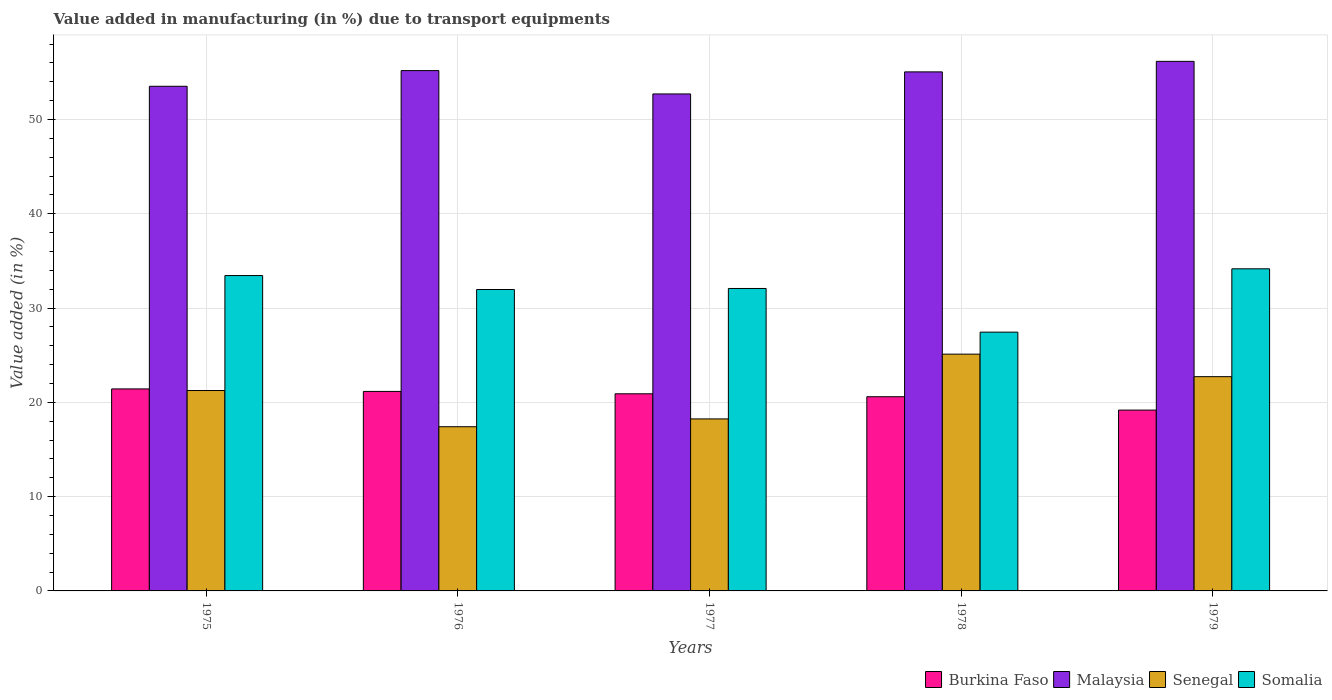How many different coloured bars are there?
Keep it short and to the point. 4. How many groups of bars are there?
Your answer should be compact. 5. What is the percentage of value added in manufacturing due to transport equipments in Somalia in 1978?
Ensure brevity in your answer.  27.45. Across all years, what is the maximum percentage of value added in manufacturing due to transport equipments in Somalia?
Offer a very short reply. 34.16. Across all years, what is the minimum percentage of value added in manufacturing due to transport equipments in Malaysia?
Keep it short and to the point. 52.71. In which year was the percentage of value added in manufacturing due to transport equipments in Somalia maximum?
Provide a short and direct response. 1979. In which year was the percentage of value added in manufacturing due to transport equipments in Burkina Faso minimum?
Ensure brevity in your answer.  1979. What is the total percentage of value added in manufacturing due to transport equipments in Malaysia in the graph?
Give a very brief answer. 272.64. What is the difference between the percentage of value added in manufacturing due to transport equipments in Malaysia in 1975 and that in 1979?
Make the answer very short. -2.65. What is the difference between the percentage of value added in manufacturing due to transport equipments in Somalia in 1975 and the percentage of value added in manufacturing due to transport equipments in Malaysia in 1979?
Offer a very short reply. -22.72. What is the average percentage of value added in manufacturing due to transport equipments in Senegal per year?
Ensure brevity in your answer.  20.95. In the year 1978, what is the difference between the percentage of value added in manufacturing due to transport equipments in Burkina Faso and percentage of value added in manufacturing due to transport equipments in Malaysia?
Your response must be concise. -34.45. In how many years, is the percentage of value added in manufacturing due to transport equipments in Somalia greater than 36 %?
Your answer should be compact. 0. What is the ratio of the percentage of value added in manufacturing due to transport equipments in Malaysia in 1975 to that in 1977?
Ensure brevity in your answer.  1.02. Is the percentage of value added in manufacturing due to transport equipments in Burkina Faso in 1976 less than that in 1977?
Provide a short and direct response. No. Is the difference between the percentage of value added in manufacturing due to transport equipments in Burkina Faso in 1975 and 1976 greater than the difference between the percentage of value added in manufacturing due to transport equipments in Malaysia in 1975 and 1976?
Your response must be concise. Yes. What is the difference between the highest and the second highest percentage of value added in manufacturing due to transport equipments in Senegal?
Your answer should be compact. 2.39. What is the difference between the highest and the lowest percentage of value added in manufacturing due to transport equipments in Somalia?
Keep it short and to the point. 6.72. In how many years, is the percentage of value added in manufacturing due to transport equipments in Somalia greater than the average percentage of value added in manufacturing due to transport equipments in Somalia taken over all years?
Give a very brief answer. 4. What does the 4th bar from the left in 1975 represents?
Provide a short and direct response. Somalia. What does the 4th bar from the right in 1978 represents?
Your answer should be compact. Burkina Faso. How many bars are there?
Offer a very short reply. 20. Are all the bars in the graph horizontal?
Provide a succinct answer. No. Does the graph contain grids?
Ensure brevity in your answer.  Yes. How are the legend labels stacked?
Give a very brief answer. Horizontal. What is the title of the graph?
Your response must be concise. Value added in manufacturing (in %) due to transport equipments. What is the label or title of the Y-axis?
Keep it short and to the point. Value added (in %). What is the Value added (in %) in Burkina Faso in 1975?
Provide a short and direct response. 21.43. What is the Value added (in %) in Malaysia in 1975?
Provide a short and direct response. 53.52. What is the Value added (in %) of Senegal in 1975?
Provide a short and direct response. 21.26. What is the Value added (in %) of Somalia in 1975?
Your response must be concise. 33.45. What is the Value added (in %) in Burkina Faso in 1976?
Offer a terse response. 21.16. What is the Value added (in %) of Malaysia in 1976?
Make the answer very short. 55.19. What is the Value added (in %) in Senegal in 1976?
Keep it short and to the point. 17.42. What is the Value added (in %) of Somalia in 1976?
Provide a succinct answer. 31.97. What is the Value added (in %) of Burkina Faso in 1977?
Ensure brevity in your answer.  20.91. What is the Value added (in %) in Malaysia in 1977?
Ensure brevity in your answer.  52.71. What is the Value added (in %) in Senegal in 1977?
Ensure brevity in your answer.  18.24. What is the Value added (in %) in Somalia in 1977?
Offer a terse response. 32.08. What is the Value added (in %) in Burkina Faso in 1978?
Offer a terse response. 20.6. What is the Value added (in %) of Malaysia in 1978?
Give a very brief answer. 55.05. What is the Value added (in %) of Senegal in 1978?
Offer a terse response. 25.11. What is the Value added (in %) of Somalia in 1978?
Keep it short and to the point. 27.45. What is the Value added (in %) in Burkina Faso in 1979?
Offer a terse response. 19.18. What is the Value added (in %) in Malaysia in 1979?
Your response must be concise. 56.17. What is the Value added (in %) in Senegal in 1979?
Your answer should be compact. 22.72. What is the Value added (in %) in Somalia in 1979?
Provide a short and direct response. 34.16. Across all years, what is the maximum Value added (in %) in Burkina Faso?
Your answer should be compact. 21.43. Across all years, what is the maximum Value added (in %) in Malaysia?
Your response must be concise. 56.17. Across all years, what is the maximum Value added (in %) in Senegal?
Provide a succinct answer. 25.11. Across all years, what is the maximum Value added (in %) in Somalia?
Your answer should be very brief. 34.16. Across all years, what is the minimum Value added (in %) of Burkina Faso?
Provide a succinct answer. 19.18. Across all years, what is the minimum Value added (in %) in Malaysia?
Your answer should be very brief. 52.71. Across all years, what is the minimum Value added (in %) in Senegal?
Make the answer very short. 17.42. Across all years, what is the minimum Value added (in %) in Somalia?
Give a very brief answer. 27.45. What is the total Value added (in %) in Burkina Faso in the graph?
Offer a very short reply. 103.27. What is the total Value added (in %) in Malaysia in the graph?
Your response must be concise. 272.64. What is the total Value added (in %) in Senegal in the graph?
Keep it short and to the point. 104.75. What is the total Value added (in %) of Somalia in the graph?
Provide a succinct answer. 159.11. What is the difference between the Value added (in %) of Burkina Faso in 1975 and that in 1976?
Make the answer very short. 0.26. What is the difference between the Value added (in %) in Malaysia in 1975 and that in 1976?
Make the answer very short. -1.67. What is the difference between the Value added (in %) in Senegal in 1975 and that in 1976?
Your response must be concise. 3.84. What is the difference between the Value added (in %) in Somalia in 1975 and that in 1976?
Keep it short and to the point. 1.48. What is the difference between the Value added (in %) in Burkina Faso in 1975 and that in 1977?
Provide a short and direct response. 0.52. What is the difference between the Value added (in %) of Malaysia in 1975 and that in 1977?
Provide a succinct answer. 0.81. What is the difference between the Value added (in %) in Senegal in 1975 and that in 1977?
Offer a very short reply. 3.01. What is the difference between the Value added (in %) in Somalia in 1975 and that in 1977?
Provide a short and direct response. 1.37. What is the difference between the Value added (in %) in Burkina Faso in 1975 and that in 1978?
Keep it short and to the point. 0.83. What is the difference between the Value added (in %) of Malaysia in 1975 and that in 1978?
Offer a very short reply. -1.53. What is the difference between the Value added (in %) in Senegal in 1975 and that in 1978?
Your answer should be very brief. -3.86. What is the difference between the Value added (in %) in Somalia in 1975 and that in 1978?
Provide a succinct answer. 6. What is the difference between the Value added (in %) of Burkina Faso in 1975 and that in 1979?
Offer a very short reply. 2.25. What is the difference between the Value added (in %) in Malaysia in 1975 and that in 1979?
Your response must be concise. -2.65. What is the difference between the Value added (in %) of Senegal in 1975 and that in 1979?
Make the answer very short. -1.47. What is the difference between the Value added (in %) in Somalia in 1975 and that in 1979?
Provide a short and direct response. -0.71. What is the difference between the Value added (in %) in Burkina Faso in 1976 and that in 1977?
Offer a terse response. 0.25. What is the difference between the Value added (in %) of Malaysia in 1976 and that in 1977?
Your answer should be compact. 2.48. What is the difference between the Value added (in %) of Senegal in 1976 and that in 1977?
Offer a very short reply. -0.83. What is the difference between the Value added (in %) of Somalia in 1976 and that in 1977?
Provide a succinct answer. -0.11. What is the difference between the Value added (in %) of Burkina Faso in 1976 and that in 1978?
Offer a terse response. 0.56. What is the difference between the Value added (in %) in Malaysia in 1976 and that in 1978?
Make the answer very short. 0.14. What is the difference between the Value added (in %) of Senegal in 1976 and that in 1978?
Your answer should be compact. -7.7. What is the difference between the Value added (in %) in Somalia in 1976 and that in 1978?
Provide a short and direct response. 4.52. What is the difference between the Value added (in %) in Burkina Faso in 1976 and that in 1979?
Provide a short and direct response. 1.98. What is the difference between the Value added (in %) of Malaysia in 1976 and that in 1979?
Your response must be concise. -0.98. What is the difference between the Value added (in %) in Senegal in 1976 and that in 1979?
Offer a terse response. -5.31. What is the difference between the Value added (in %) of Somalia in 1976 and that in 1979?
Offer a very short reply. -2.19. What is the difference between the Value added (in %) in Burkina Faso in 1977 and that in 1978?
Offer a very short reply. 0.31. What is the difference between the Value added (in %) in Malaysia in 1977 and that in 1978?
Provide a succinct answer. -2.34. What is the difference between the Value added (in %) of Senegal in 1977 and that in 1978?
Keep it short and to the point. -6.87. What is the difference between the Value added (in %) of Somalia in 1977 and that in 1978?
Your answer should be very brief. 4.63. What is the difference between the Value added (in %) of Burkina Faso in 1977 and that in 1979?
Your answer should be compact. 1.73. What is the difference between the Value added (in %) of Malaysia in 1977 and that in 1979?
Your response must be concise. -3.46. What is the difference between the Value added (in %) of Senegal in 1977 and that in 1979?
Ensure brevity in your answer.  -4.48. What is the difference between the Value added (in %) in Somalia in 1977 and that in 1979?
Provide a short and direct response. -2.09. What is the difference between the Value added (in %) in Burkina Faso in 1978 and that in 1979?
Your answer should be compact. 1.42. What is the difference between the Value added (in %) in Malaysia in 1978 and that in 1979?
Offer a terse response. -1.12. What is the difference between the Value added (in %) in Senegal in 1978 and that in 1979?
Offer a very short reply. 2.39. What is the difference between the Value added (in %) of Somalia in 1978 and that in 1979?
Offer a terse response. -6.72. What is the difference between the Value added (in %) in Burkina Faso in 1975 and the Value added (in %) in Malaysia in 1976?
Provide a succinct answer. -33.76. What is the difference between the Value added (in %) in Burkina Faso in 1975 and the Value added (in %) in Senegal in 1976?
Make the answer very short. 4.01. What is the difference between the Value added (in %) in Burkina Faso in 1975 and the Value added (in %) in Somalia in 1976?
Your response must be concise. -10.54. What is the difference between the Value added (in %) in Malaysia in 1975 and the Value added (in %) in Senegal in 1976?
Make the answer very short. 36.11. What is the difference between the Value added (in %) in Malaysia in 1975 and the Value added (in %) in Somalia in 1976?
Offer a terse response. 21.55. What is the difference between the Value added (in %) in Senegal in 1975 and the Value added (in %) in Somalia in 1976?
Your answer should be compact. -10.71. What is the difference between the Value added (in %) of Burkina Faso in 1975 and the Value added (in %) of Malaysia in 1977?
Make the answer very short. -31.29. What is the difference between the Value added (in %) of Burkina Faso in 1975 and the Value added (in %) of Senegal in 1977?
Your answer should be very brief. 3.18. What is the difference between the Value added (in %) of Burkina Faso in 1975 and the Value added (in %) of Somalia in 1977?
Provide a succinct answer. -10.65. What is the difference between the Value added (in %) of Malaysia in 1975 and the Value added (in %) of Senegal in 1977?
Give a very brief answer. 35.28. What is the difference between the Value added (in %) of Malaysia in 1975 and the Value added (in %) of Somalia in 1977?
Make the answer very short. 21.44. What is the difference between the Value added (in %) of Senegal in 1975 and the Value added (in %) of Somalia in 1977?
Ensure brevity in your answer.  -10.82. What is the difference between the Value added (in %) of Burkina Faso in 1975 and the Value added (in %) of Malaysia in 1978?
Provide a short and direct response. -33.63. What is the difference between the Value added (in %) of Burkina Faso in 1975 and the Value added (in %) of Senegal in 1978?
Your response must be concise. -3.69. What is the difference between the Value added (in %) of Burkina Faso in 1975 and the Value added (in %) of Somalia in 1978?
Offer a very short reply. -6.02. What is the difference between the Value added (in %) in Malaysia in 1975 and the Value added (in %) in Senegal in 1978?
Your answer should be very brief. 28.41. What is the difference between the Value added (in %) of Malaysia in 1975 and the Value added (in %) of Somalia in 1978?
Offer a terse response. 26.08. What is the difference between the Value added (in %) of Senegal in 1975 and the Value added (in %) of Somalia in 1978?
Your answer should be very brief. -6.19. What is the difference between the Value added (in %) in Burkina Faso in 1975 and the Value added (in %) in Malaysia in 1979?
Offer a terse response. -34.74. What is the difference between the Value added (in %) in Burkina Faso in 1975 and the Value added (in %) in Senegal in 1979?
Your answer should be compact. -1.3. What is the difference between the Value added (in %) of Burkina Faso in 1975 and the Value added (in %) of Somalia in 1979?
Your response must be concise. -12.74. What is the difference between the Value added (in %) of Malaysia in 1975 and the Value added (in %) of Senegal in 1979?
Your answer should be very brief. 30.8. What is the difference between the Value added (in %) in Malaysia in 1975 and the Value added (in %) in Somalia in 1979?
Your response must be concise. 19.36. What is the difference between the Value added (in %) of Senegal in 1975 and the Value added (in %) of Somalia in 1979?
Provide a succinct answer. -12.91. What is the difference between the Value added (in %) of Burkina Faso in 1976 and the Value added (in %) of Malaysia in 1977?
Keep it short and to the point. -31.55. What is the difference between the Value added (in %) of Burkina Faso in 1976 and the Value added (in %) of Senegal in 1977?
Your answer should be compact. 2.92. What is the difference between the Value added (in %) of Burkina Faso in 1976 and the Value added (in %) of Somalia in 1977?
Keep it short and to the point. -10.92. What is the difference between the Value added (in %) in Malaysia in 1976 and the Value added (in %) in Senegal in 1977?
Ensure brevity in your answer.  36.94. What is the difference between the Value added (in %) of Malaysia in 1976 and the Value added (in %) of Somalia in 1977?
Provide a short and direct response. 23.11. What is the difference between the Value added (in %) of Senegal in 1976 and the Value added (in %) of Somalia in 1977?
Your answer should be compact. -14.66. What is the difference between the Value added (in %) of Burkina Faso in 1976 and the Value added (in %) of Malaysia in 1978?
Provide a succinct answer. -33.89. What is the difference between the Value added (in %) in Burkina Faso in 1976 and the Value added (in %) in Senegal in 1978?
Keep it short and to the point. -3.95. What is the difference between the Value added (in %) in Burkina Faso in 1976 and the Value added (in %) in Somalia in 1978?
Your answer should be compact. -6.29. What is the difference between the Value added (in %) in Malaysia in 1976 and the Value added (in %) in Senegal in 1978?
Your answer should be very brief. 30.07. What is the difference between the Value added (in %) in Malaysia in 1976 and the Value added (in %) in Somalia in 1978?
Ensure brevity in your answer.  27.74. What is the difference between the Value added (in %) of Senegal in 1976 and the Value added (in %) of Somalia in 1978?
Keep it short and to the point. -10.03. What is the difference between the Value added (in %) in Burkina Faso in 1976 and the Value added (in %) in Malaysia in 1979?
Ensure brevity in your answer.  -35.01. What is the difference between the Value added (in %) of Burkina Faso in 1976 and the Value added (in %) of Senegal in 1979?
Give a very brief answer. -1.56. What is the difference between the Value added (in %) of Burkina Faso in 1976 and the Value added (in %) of Somalia in 1979?
Make the answer very short. -13. What is the difference between the Value added (in %) of Malaysia in 1976 and the Value added (in %) of Senegal in 1979?
Make the answer very short. 32.46. What is the difference between the Value added (in %) of Malaysia in 1976 and the Value added (in %) of Somalia in 1979?
Your answer should be very brief. 21.02. What is the difference between the Value added (in %) in Senegal in 1976 and the Value added (in %) in Somalia in 1979?
Give a very brief answer. -16.75. What is the difference between the Value added (in %) of Burkina Faso in 1977 and the Value added (in %) of Malaysia in 1978?
Offer a terse response. -34.14. What is the difference between the Value added (in %) in Burkina Faso in 1977 and the Value added (in %) in Senegal in 1978?
Your answer should be very brief. -4.2. What is the difference between the Value added (in %) in Burkina Faso in 1977 and the Value added (in %) in Somalia in 1978?
Make the answer very short. -6.54. What is the difference between the Value added (in %) in Malaysia in 1977 and the Value added (in %) in Senegal in 1978?
Offer a very short reply. 27.6. What is the difference between the Value added (in %) in Malaysia in 1977 and the Value added (in %) in Somalia in 1978?
Offer a terse response. 25.27. What is the difference between the Value added (in %) of Senegal in 1977 and the Value added (in %) of Somalia in 1978?
Offer a very short reply. -9.2. What is the difference between the Value added (in %) of Burkina Faso in 1977 and the Value added (in %) of Malaysia in 1979?
Keep it short and to the point. -35.26. What is the difference between the Value added (in %) in Burkina Faso in 1977 and the Value added (in %) in Senegal in 1979?
Ensure brevity in your answer.  -1.82. What is the difference between the Value added (in %) of Burkina Faso in 1977 and the Value added (in %) of Somalia in 1979?
Provide a succinct answer. -13.25. What is the difference between the Value added (in %) of Malaysia in 1977 and the Value added (in %) of Senegal in 1979?
Make the answer very short. 29.99. What is the difference between the Value added (in %) in Malaysia in 1977 and the Value added (in %) in Somalia in 1979?
Keep it short and to the point. 18.55. What is the difference between the Value added (in %) of Senegal in 1977 and the Value added (in %) of Somalia in 1979?
Keep it short and to the point. -15.92. What is the difference between the Value added (in %) of Burkina Faso in 1978 and the Value added (in %) of Malaysia in 1979?
Make the answer very short. -35.57. What is the difference between the Value added (in %) of Burkina Faso in 1978 and the Value added (in %) of Senegal in 1979?
Ensure brevity in your answer.  -2.13. What is the difference between the Value added (in %) in Burkina Faso in 1978 and the Value added (in %) in Somalia in 1979?
Make the answer very short. -13.57. What is the difference between the Value added (in %) in Malaysia in 1978 and the Value added (in %) in Senegal in 1979?
Offer a very short reply. 32.33. What is the difference between the Value added (in %) of Malaysia in 1978 and the Value added (in %) of Somalia in 1979?
Ensure brevity in your answer.  20.89. What is the difference between the Value added (in %) in Senegal in 1978 and the Value added (in %) in Somalia in 1979?
Ensure brevity in your answer.  -9.05. What is the average Value added (in %) of Burkina Faso per year?
Make the answer very short. 20.65. What is the average Value added (in %) of Malaysia per year?
Give a very brief answer. 54.53. What is the average Value added (in %) in Senegal per year?
Make the answer very short. 20.95. What is the average Value added (in %) of Somalia per year?
Offer a terse response. 31.82. In the year 1975, what is the difference between the Value added (in %) of Burkina Faso and Value added (in %) of Malaysia?
Your response must be concise. -32.1. In the year 1975, what is the difference between the Value added (in %) in Burkina Faso and Value added (in %) in Senegal?
Offer a terse response. 0.17. In the year 1975, what is the difference between the Value added (in %) in Burkina Faso and Value added (in %) in Somalia?
Provide a short and direct response. -12.02. In the year 1975, what is the difference between the Value added (in %) in Malaysia and Value added (in %) in Senegal?
Your response must be concise. 32.27. In the year 1975, what is the difference between the Value added (in %) in Malaysia and Value added (in %) in Somalia?
Your answer should be very brief. 20.07. In the year 1975, what is the difference between the Value added (in %) in Senegal and Value added (in %) in Somalia?
Make the answer very short. -12.19. In the year 1976, what is the difference between the Value added (in %) in Burkina Faso and Value added (in %) in Malaysia?
Offer a terse response. -34.03. In the year 1976, what is the difference between the Value added (in %) of Burkina Faso and Value added (in %) of Senegal?
Your answer should be compact. 3.75. In the year 1976, what is the difference between the Value added (in %) in Burkina Faso and Value added (in %) in Somalia?
Offer a terse response. -10.81. In the year 1976, what is the difference between the Value added (in %) of Malaysia and Value added (in %) of Senegal?
Your response must be concise. 37.77. In the year 1976, what is the difference between the Value added (in %) in Malaysia and Value added (in %) in Somalia?
Keep it short and to the point. 23.22. In the year 1976, what is the difference between the Value added (in %) in Senegal and Value added (in %) in Somalia?
Ensure brevity in your answer.  -14.55. In the year 1977, what is the difference between the Value added (in %) in Burkina Faso and Value added (in %) in Malaysia?
Provide a succinct answer. -31.8. In the year 1977, what is the difference between the Value added (in %) in Burkina Faso and Value added (in %) in Senegal?
Offer a terse response. 2.67. In the year 1977, what is the difference between the Value added (in %) of Burkina Faso and Value added (in %) of Somalia?
Your answer should be very brief. -11.17. In the year 1977, what is the difference between the Value added (in %) in Malaysia and Value added (in %) in Senegal?
Offer a terse response. 34.47. In the year 1977, what is the difference between the Value added (in %) in Malaysia and Value added (in %) in Somalia?
Your response must be concise. 20.63. In the year 1977, what is the difference between the Value added (in %) in Senegal and Value added (in %) in Somalia?
Your answer should be very brief. -13.83. In the year 1978, what is the difference between the Value added (in %) in Burkina Faso and Value added (in %) in Malaysia?
Provide a succinct answer. -34.45. In the year 1978, what is the difference between the Value added (in %) in Burkina Faso and Value added (in %) in Senegal?
Offer a very short reply. -4.52. In the year 1978, what is the difference between the Value added (in %) of Burkina Faso and Value added (in %) of Somalia?
Provide a short and direct response. -6.85. In the year 1978, what is the difference between the Value added (in %) in Malaysia and Value added (in %) in Senegal?
Offer a very short reply. 29.94. In the year 1978, what is the difference between the Value added (in %) in Malaysia and Value added (in %) in Somalia?
Make the answer very short. 27.61. In the year 1978, what is the difference between the Value added (in %) of Senegal and Value added (in %) of Somalia?
Ensure brevity in your answer.  -2.33. In the year 1979, what is the difference between the Value added (in %) in Burkina Faso and Value added (in %) in Malaysia?
Give a very brief answer. -36.99. In the year 1979, what is the difference between the Value added (in %) in Burkina Faso and Value added (in %) in Senegal?
Provide a succinct answer. -3.54. In the year 1979, what is the difference between the Value added (in %) of Burkina Faso and Value added (in %) of Somalia?
Keep it short and to the point. -14.98. In the year 1979, what is the difference between the Value added (in %) of Malaysia and Value added (in %) of Senegal?
Your response must be concise. 33.44. In the year 1979, what is the difference between the Value added (in %) of Malaysia and Value added (in %) of Somalia?
Give a very brief answer. 22. In the year 1979, what is the difference between the Value added (in %) of Senegal and Value added (in %) of Somalia?
Ensure brevity in your answer.  -11.44. What is the ratio of the Value added (in %) in Burkina Faso in 1975 to that in 1976?
Offer a very short reply. 1.01. What is the ratio of the Value added (in %) in Malaysia in 1975 to that in 1976?
Your answer should be compact. 0.97. What is the ratio of the Value added (in %) of Senegal in 1975 to that in 1976?
Provide a succinct answer. 1.22. What is the ratio of the Value added (in %) in Somalia in 1975 to that in 1976?
Offer a terse response. 1.05. What is the ratio of the Value added (in %) in Burkina Faso in 1975 to that in 1977?
Keep it short and to the point. 1.02. What is the ratio of the Value added (in %) in Malaysia in 1975 to that in 1977?
Offer a terse response. 1.02. What is the ratio of the Value added (in %) in Senegal in 1975 to that in 1977?
Your response must be concise. 1.17. What is the ratio of the Value added (in %) in Somalia in 1975 to that in 1977?
Ensure brevity in your answer.  1.04. What is the ratio of the Value added (in %) in Burkina Faso in 1975 to that in 1978?
Offer a terse response. 1.04. What is the ratio of the Value added (in %) in Malaysia in 1975 to that in 1978?
Provide a short and direct response. 0.97. What is the ratio of the Value added (in %) of Senegal in 1975 to that in 1978?
Your answer should be compact. 0.85. What is the ratio of the Value added (in %) of Somalia in 1975 to that in 1978?
Offer a terse response. 1.22. What is the ratio of the Value added (in %) in Burkina Faso in 1975 to that in 1979?
Offer a very short reply. 1.12. What is the ratio of the Value added (in %) in Malaysia in 1975 to that in 1979?
Offer a terse response. 0.95. What is the ratio of the Value added (in %) of Senegal in 1975 to that in 1979?
Your response must be concise. 0.94. What is the ratio of the Value added (in %) in Somalia in 1975 to that in 1979?
Your answer should be very brief. 0.98. What is the ratio of the Value added (in %) in Malaysia in 1976 to that in 1977?
Ensure brevity in your answer.  1.05. What is the ratio of the Value added (in %) in Senegal in 1976 to that in 1977?
Give a very brief answer. 0.95. What is the ratio of the Value added (in %) in Burkina Faso in 1976 to that in 1978?
Make the answer very short. 1.03. What is the ratio of the Value added (in %) in Malaysia in 1976 to that in 1978?
Provide a short and direct response. 1. What is the ratio of the Value added (in %) of Senegal in 1976 to that in 1978?
Provide a short and direct response. 0.69. What is the ratio of the Value added (in %) of Somalia in 1976 to that in 1978?
Keep it short and to the point. 1.16. What is the ratio of the Value added (in %) in Burkina Faso in 1976 to that in 1979?
Offer a terse response. 1.1. What is the ratio of the Value added (in %) of Malaysia in 1976 to that in 1979?
Provide a succinct answer. 0.98. What is the ratio of the Value added (in %) of Senegal in 1976 to that in 1979?
Your answer should be very brief. 0.77. What is the ratio of the Value added (in %) of Somalia in 1976 to that in 1979?
Offer a very short reply. 0.94. What is the ratio of the Value added (in %) in Burkina Faso in 1977 to that in 1978?
Provide a succinct answer. 1.02. What is the ratio of the Value added (in %) in Malaysia in 1977 to that in 1978?
Your answer should be compact. 0.96. What is the ratio of the Value added (in %) of Senegal in 1977 to that in 1978?
Your answer should be very brief. 0.73. What is the ratio of the Value added (in %) in Somalia in 1977 to that in 1978?
Offer a very short reply. 1.17. What is the ratio of the Value added (in %) of Burkina Faso in 1977 to that in 1979?
Keep it short and to the point. 1.09. What is the ratio of the Value added (in %) of Malaysia in 1977 to that in 1979?
Provide a succinct answer. 0.94. What is the ratio of the Value added (in %) in Senegal in 1977 to that in 1979?
Give a very brief answer. 0.8. What is the ratio of the Value added (in %) of Somalia in 1977 to that in 1979?
Give a very brief answer. 0.94. What is the ratio of the Value added (in %) of Burkina Faso in 1978 to that in 1979?
Make the answer very short. 1.07. What is the ratio of the Value added (in %) of Malaysia in 1978 to that in 1979?
Your response must be concise. 0.98. What is the ratio of the Value added (in %) in Senegal in 1978 to that in 1979?
Make the answer very short. 1.11. What is the ratio of the Value added (in %) in Somalia in 1978 to that in 1979?
Provide a succinct answer. 0.8. What is the difference between the highest and the second highest Value added (in %) in Burkina Faso?
Keep it short and to the point. 0.26. What is the difference between the highest and the second highest Value added (in %) in Malaysia?
Offer a very short reply. 0.98. What is the difference between the highest and the second highest Value added (in %) in Senegal?
Provide a short and direct response. 2.39. What is the difference between the highest and the second highest Value added (in %) of Somalia?
Offer a terse response. 0.71. What is the difference between the highest and the lowest Value added (in %) of Burkina Faso?
Offer a terse response. 2.25. What is the difference between the highest and the lowest Value added (in %) in Malaysia?
Make the answer very short. 3.46. What is the difference between the highest and the lowest Value added (in %) in Senegal?
Give a very brief answer. 7.7. What is the difference between the highest and the lowest Value added (in %) in Somalia?
Offer a terse response. 6.72. 